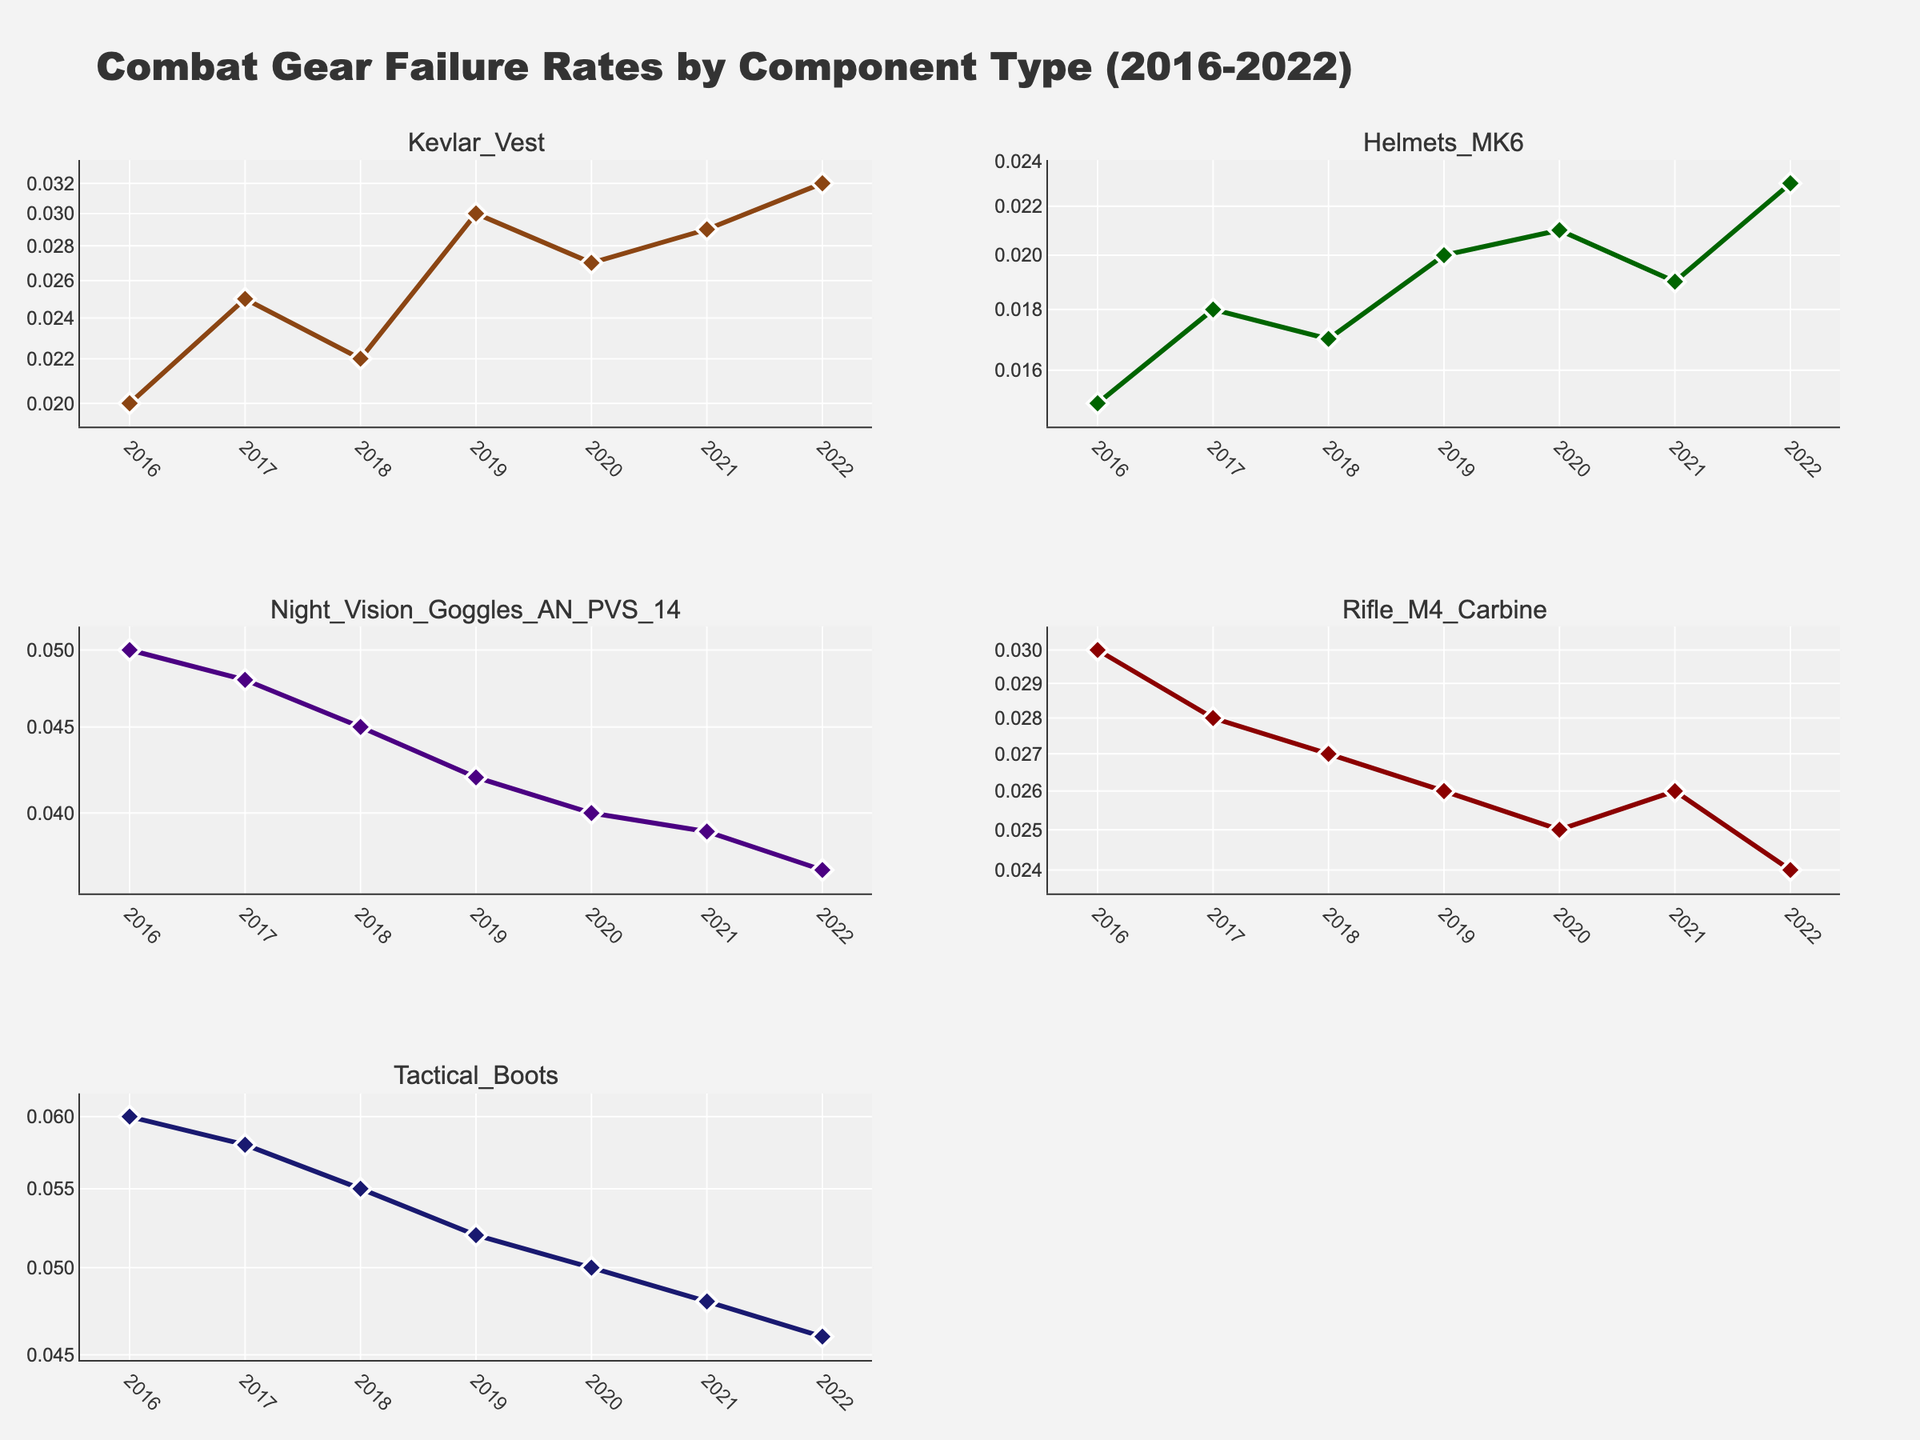Which component type has the highest failure rate in 2016? The data shows subplots for each component type. By observing the y-axis for 2016, Tactical Boots have the highest failure rate.
Answer: Tactical Boots How did the failure rate of Rifle M4 Carbine change from 2016 to 2022? Look at the subplot for Rifle M4 Carbine. In 2016, the failure rate is higher than in 2022; it decreases from 0.03 to 0.024.
Answer: Decrease Which component showed a decreasing trend in failure rates over time? Examine the trend lines for each component. Night Vision Goggles AN PVS 14 show a consistent decrease each year from 2016 to 2022.
Answer: Night Vision Goggles AN PVS 14 What is the failure rate of Kevlar Vest in 2020? Check the subplot for Kevlar Vest and locate the y-value for the year 2020. The failure rate is 0.027.
Answer: 0.027 Between Helmets MK6 and Kevlar Vest, which had the lower failure rate in 2022? Compare the end points of the subplots for Helmets MK6 and Kevlar Vest in 2022. Helmets MK6 has a failure rate of 0.023, while Kevlar Vest is 0.032, making Helmets MK6 lower.
Answer: Helmets MK6 How many component types are shown in the figure? Count the number of unique subplots, each representing a different component type. There are five subplots.
Answer: 5 Which year showed the maximum failure rate for Tactical Boots? Review the subplot for Tactical Boots and find the highest y-value. The maximum failure rate is in 2016 with a value of 0.06.
Answer: 2016 Does any component type have a failure rate below 0.02 after 2016? Examine all the subplots after 2016 to check if any failure rate goes below 0.02. None of the components have a failure rate below 0.02 after 2016.
Answer: No Which component’s failure rate remains relatively constant over the analyzed years? Assess each subplot's trend line; Rifle M4 Carbine shows relatively little change across the years, staying close to 0.025-0.030.
Answer: Rifle M4 Carbine 